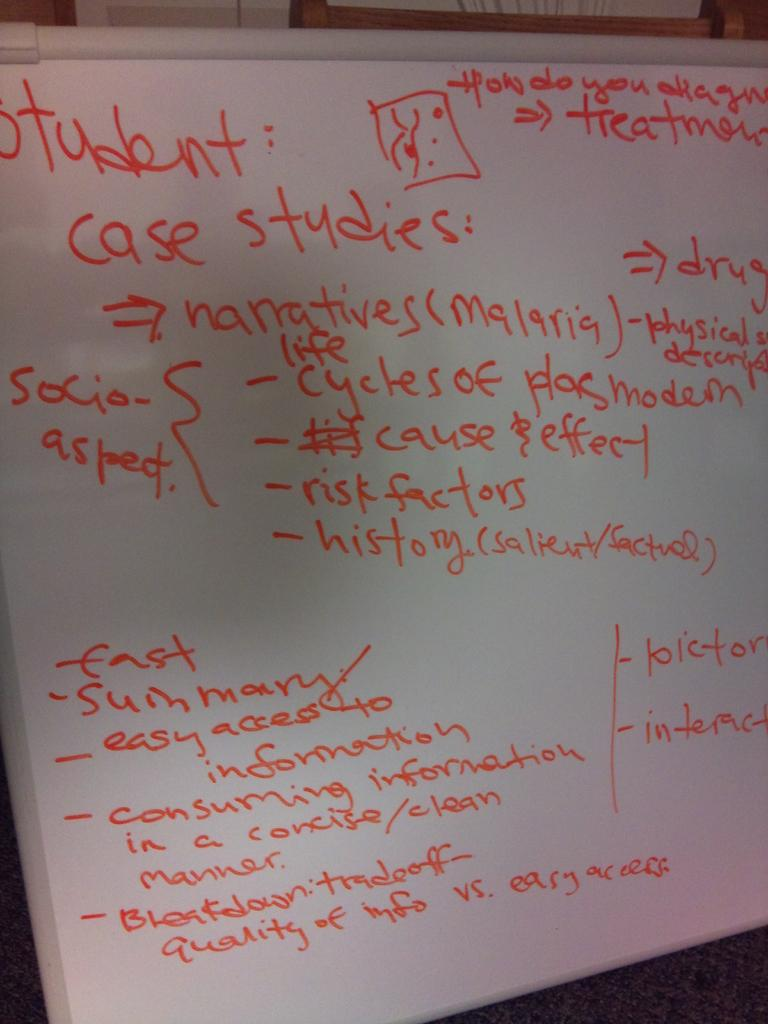<image>
Render a clear and concise summary of the photo. Orange writing on a whiteboard says student: case studies. 